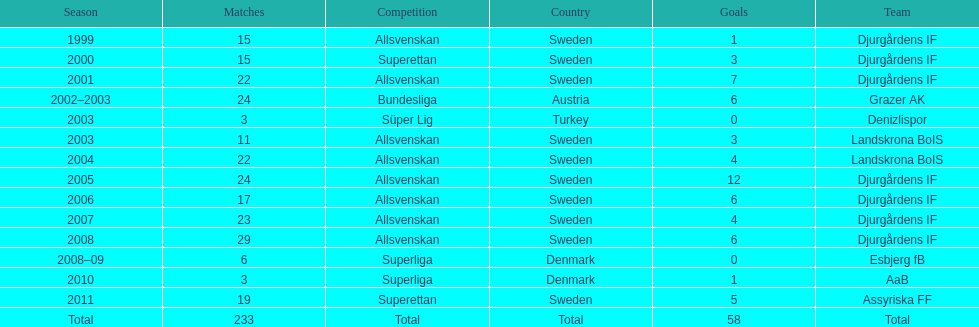What is the total number of matches? 233. 